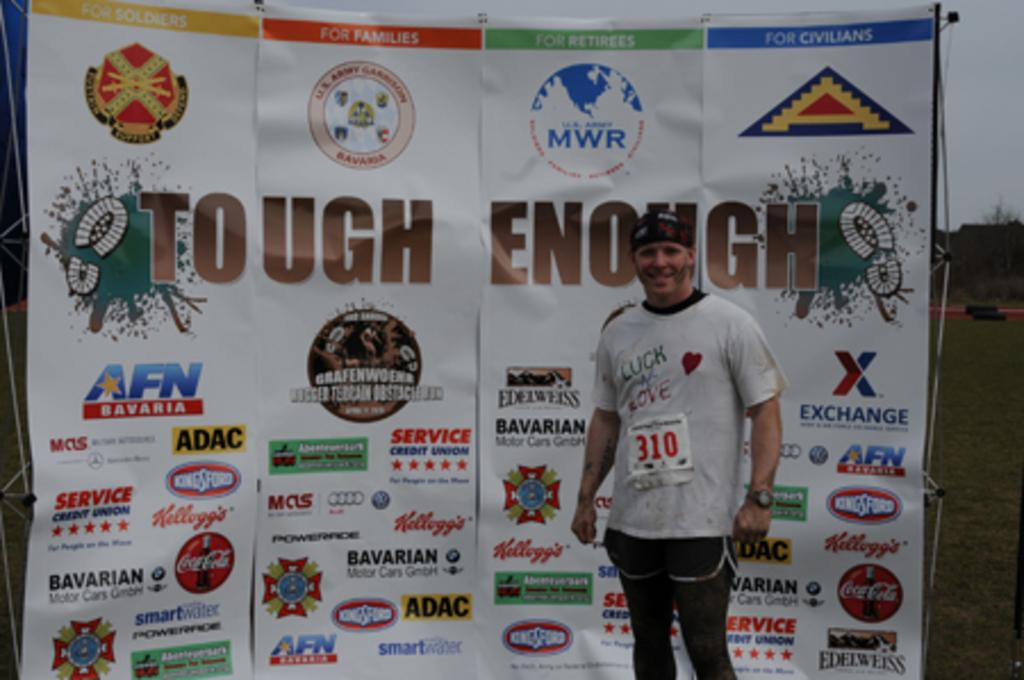<image>
Describe the image concisely. A man with the number 310 on his stomach is standing in front of a sign that says tough enough. 